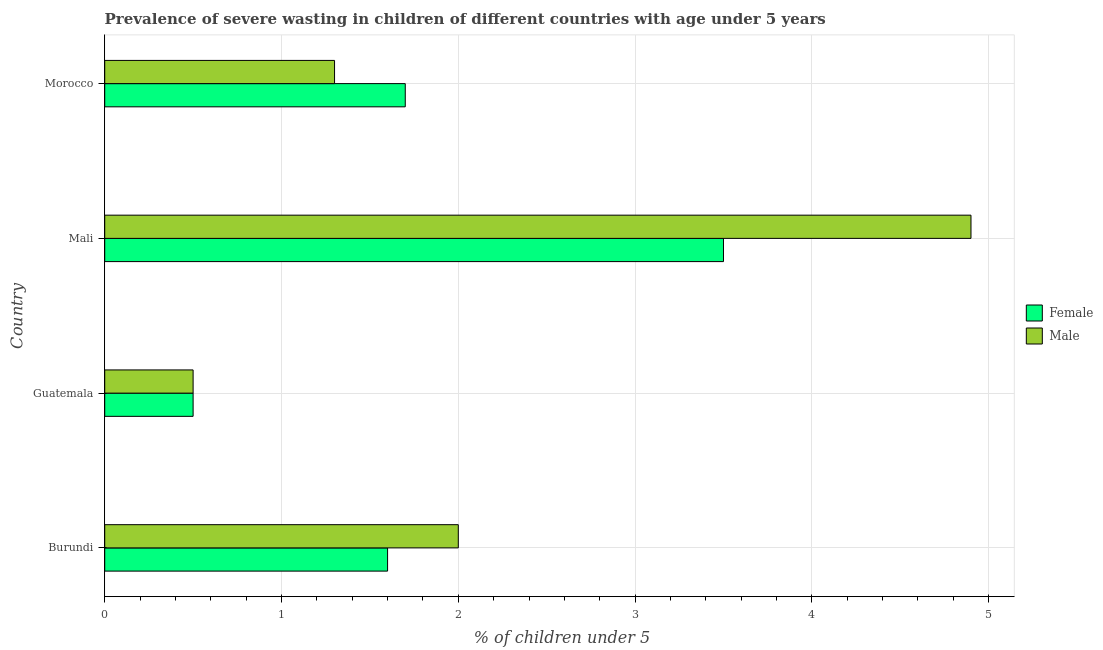How many groups of bars are there?
Make the answer very short. 4. How many bars are there on the 4th tick from the top?
Make the answer very short. 2. What is the label of the 3rd group of bars from the top?
Keep it short and to the point. Guatemala. In how many cases, is the number of bars for a given country not equal to the number of legend labels?
Offer a very short reply. 0. What is the percentage of undernourished male children in Mali?
Provide a succinct answer. 4.9. Across all countries, what is the maximum percentage of undernourished female children?
Your response must be concise. 3.5. In which country was the percentage of undernourished male children maximum?
Make the answer very short. Mali. In which country was the percentage of undernourished male children minimum?
Provide a succinct answer. Guatemala. What is the total percentage of undernourished female children in the graph?
Give a very brief answer. 7.3. What is the difference between the percentage of undernourished male children in Guatemala and the percentage of undernourished female children in Morocco?
Ensure brevity in your answer.  -1.2. What is the average percentage of undernourished male children per country?
Make the answer very short. 2.17. What is the difference between the percentage of undernourished male children and percentage of undernourished female children in Burundi?
Your answer should be very brief. 0.4. What is the ratio of the percentage of undernourished male children in Guatemala to that in Morocco?
Provide a succinct answer. 0.39. Is the percentage of undernourished female children in Burundi less than that in Mali?
Ensure brevity in your answer.  Yes. What is the difference between the highest and the second highest percentage of undernourished male children?
Give a very brief answer. 2.9. In how many countries, is the percentage of undernourished female children greater than the average percentage of undernourished female children taken over all countries?
Give a very brief answer. 1. What does the 1st bar from the bottom in Burundi represents?
Give a very brief answer. Female. How many bars are there?
Provide a succinct answer. 8. Are all the bars in the graph horizontal?
Provide a succinct answer. Yes. How many countries are there in the graph?
Provide a succinct answer. 4. What is the difference between two consecutive major ticks on the X-axis?
Your answer should be compact. 1. Are the values on the major ticks of X-axis written in scientific E-notation?
Ensure brevity in your answer.  No. How are the legend labels stacked?
Provide a short and direct response. Vertical. What is the title of the graph?
Offer a terse response. Prevalence of severe wasting in children of different countries with age under 5 years. What is the label or title of the X-axis?
Give a very brief answer.  % of children under 5. What is the  % of children under 5 of Female in Burundi?
Your answer should be compact. 1.6. What is the  % of children under 5 in Male in Burundi?
Keep it short and to the point. 2. What is the  % of children under 5 of Male in Guatemala?
Keep it short and to the point. 0.5. What is the  % of children under 5 in Male in Mali?
Ensure brevity in your answer.  4.9. What is the  % of children under 5 of Female in Morocco?
Offer a very short reply. 1.7. What is the  % of children under 5 in Male in Morocco?
Make the answer very short. 1.3. Across all countries, what is the maximum  % of children under 5 in Female?
Your answer should be very brief. 3.5. Across all countries, what is the maximum  % of children under 5 of Male?
Your response must be concise. 4.9. Across all countries, what is the minimum  % of children under 5 in Male?
Offer a very short reply. 0.5. What is the total  % of children under 5 in Male in the graph?
Provide a succinct answer. 8.7. What is the difference between the  % of children under 5 in Female in Burundi and that in Morocco?
Give a very brief answer. -0.1. What is the difference between the  % of children under 5 of Male in Burundi and that in Morocco?
Ensure brevity in your answer.  0.7. What is the difference between the  % of children under 5 in Female in Guatemala and that in Mali?
Give a very brief answer. -3. What is the difference between the  % of children under 5 of Female in Guatemala and that in Morocco?
Offer a terse response. -1.2. What is the difference between the  % of children under 5 of Male in Guatemala and that in Morocco?
Provide a succinct answer. -0.8. What is the difference between the  % of children under 5 in Female in Mali and that in Morocco?
Your answer should be compact. 1.8. What is the difference between the  % of children under 5 of Male in Mali and that in Morocco?
Offer a terse response. 3.6. What is the difference between the  % of children under 5 of Female in Burundi and the  % of children under 5 of Male in Guatemala?
Offer a very short reply. 1.1. What is the difference between the  % of children under 5 in Female in Burundi and the  % of children under 5 in Male in Mali?
Give a very brief answer. -3.3. What is the average  % of children under 5 of Female per country?
Provide a short and direct response. 1.82. What is the average  % of children under 5 of Male per country?
Your response must be concise. 2.17. What is the difference between the  % of children under 5 in Female and  % of children under 5 in Male in Guatemala?
Offer a terse response. 0. What is the difference between the  % of children under 5 in Female and  % of children under 5 in Male in Mali?
Give a very brief answer. -1.4. What is the ratio of the  % of children under 5 of Female in Burundi to that in Guatemala?
Offer a very short reply. 3.2. What is the ratio of the  % of children under 5 of Female in Burundi to that in Mali?
Provide a short and direct response. 0.46. What is the ratio of the  % of children under 5 of Male in Burundi to that in Mali?
Your response must be concise. 0.41. What is the ratio of the  % of children under 5 of Male in Burundi to that in Morocco?
Make the answer very short. 1.54. What is the ratio of the  % of children under 5 of Female in Guatemala to that in Mali?
Offer a terse response. 0.14. What is the ratio of the  % of children under 5 of Male in Guatemala to that in Mali?
Make the answer very short. 0.1. What is the ratio of the  % of children under 5 in Female in Guatemala to that in Morocco?
Your answer should be compact. 0.29. What is the ratio of the  % of children under 5 of Male in Guatemala to that in Morocco?
Your response must be concise. 0.38. What is the ratio of the  % of children under 5 of Female in Mali to that in Morocco?
Your answer should be compact. 2.06. What is the ratio of the  % of children under 5 of Male in Mali to that in Morocco?
Your response must be concise. 3.77. What is the difference between the highest and the second highest  % of children under 5 of Female?
Provide a succinct answer. 1.8. What is the difference between the highest and the second highest  % of children under 5 of Male?
Ensure brevity in your answer.  2.9. What is the difference between the highest and the lowest  % of children under 5 of Female?
Provide a short and direct response. 3. What is the difference between the highest and the lowest  % of children under 5 of Male?
Your answer should be compact. 4.4. 